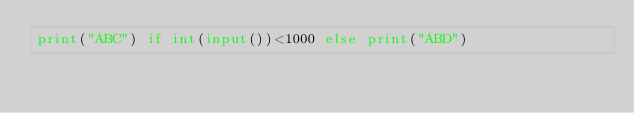Convert code to text. <code><loc_0><loc_0><loc_500><loc_500><_Python_>print("ABC") if int(input())<1000 else print("ABD")</code> 